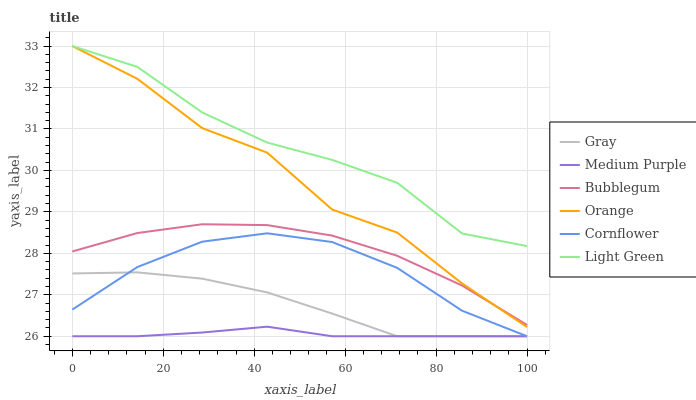Does Medium Purple have the minimum area under the curve?
Answer yes or no. Yes. Does Light Green have the maximum area under the curve?
Answer yes or no. Yes. Does Cornflower have the minimum area under the curve?
Answer yes or no. No. Does Cornflower have the maximum area under the curve?
Answer yes or no. No. Is Medium Purple the smoothest?
Answer yes or no. Yes. Is Orange the roughest?
Answer yes or no. Yes. Is Cornflower the smoothest?
Answer yes or no. No. Is Cornflower the roughest?
Answer yes or no. No. Does Gray have the lowest value?
Answer yes or no. Yes. Does Bubblegum have the lowest value?
Answer yes or no. No. Does Orange have the highest value?
Answer yes or no. Yes. Does Cornflower have the highest value?
Answer yes or no. No. Is Gray less than Bubblegum?
Answer yes or no. Yes. Is Light Green greater than Medium Purple?
Answer yes or no. Yes. Does Cornflower intersect Medium Purple?
Answer yes or no. Yes. Is Cornflower less than Medium Purple?
Answer yes or no. No. Is Cornflower greater than Medium Purple?
Answer yes or no. No. Does Gray intersect Bubblegum?
Answer yes or no. No. 